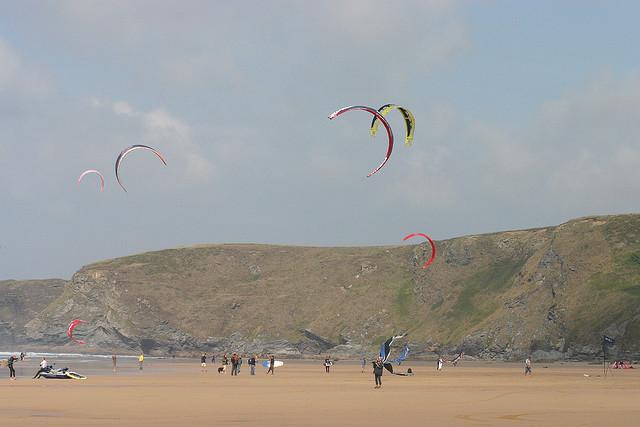How many red kites are there?
Write a very short answer. 2. What are the people doing?
Concise answer only. Flying kites. Are kites aerodynamic?
Short answer required. Yes. How many bikes are here?
Write a very short answer. 0. What activity is taking place?
Quick response, please. Kite flying. Are there people on the beach?
Give a very brief answer. Yes. 